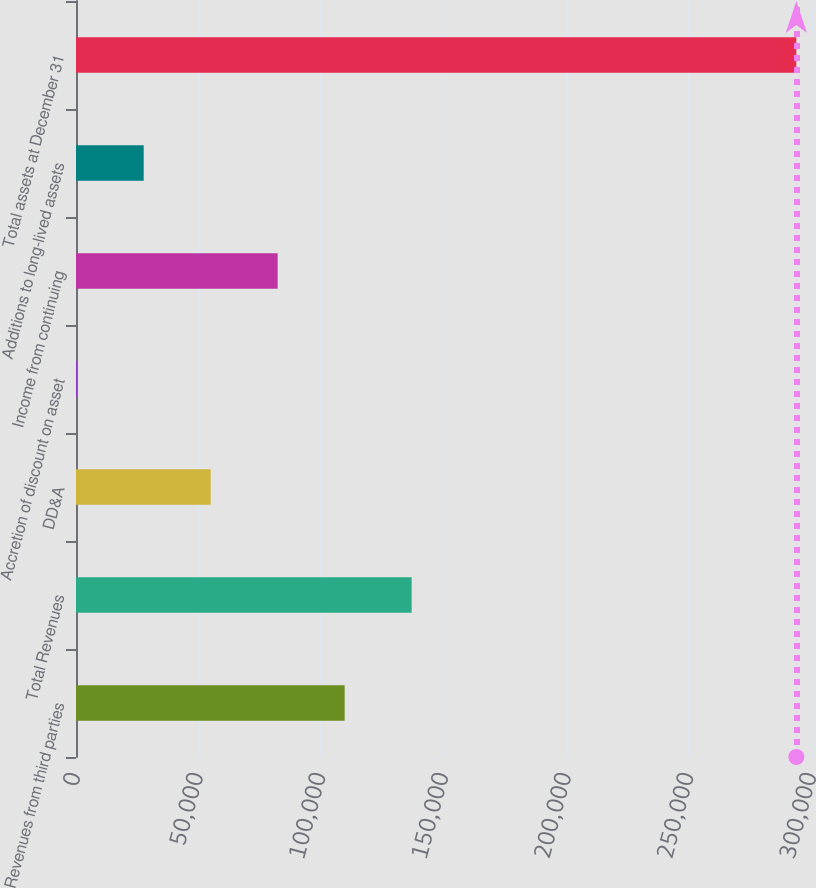Convert chart to OTSL. <chart><loc_0><loc_0><loc_500><loc_500><bar_chart><fcel>Revenues from third parties<fcel>Total Revenues<fcel>DD&A<fcel>Accretion of discount on asset<fcel>Income from continuing<fcel>Additions to long-lived assets<fcel>Total assets at December 31<nl><fcel>109507<fcel>136814<fcel>54894.2<fcel>281<fcel>82200.8<fcel>27587.6<fcel>293619<nl></chart> 